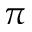<formula> <loc_0><loc_0><loc_500><loc_500>\pi</formula> 